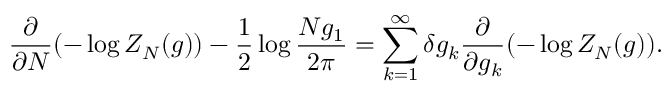Convert formula to latex. <formula><loc_0><loc_0><loc_500><loc_500>\frac { \partial } { \partial N } ( - \log Z _ { N } ( g ) ) - \frac { 1 } { 2 } \log \frac { N g _ { 1 } } { 2 \pi } = \sum _ { k = 1 } ^ { \infty } \delta g _ { k } \frac { \partial } { \partial g _ { k } } ( - \log Z _ { N } ( g ) ) .</formula> 